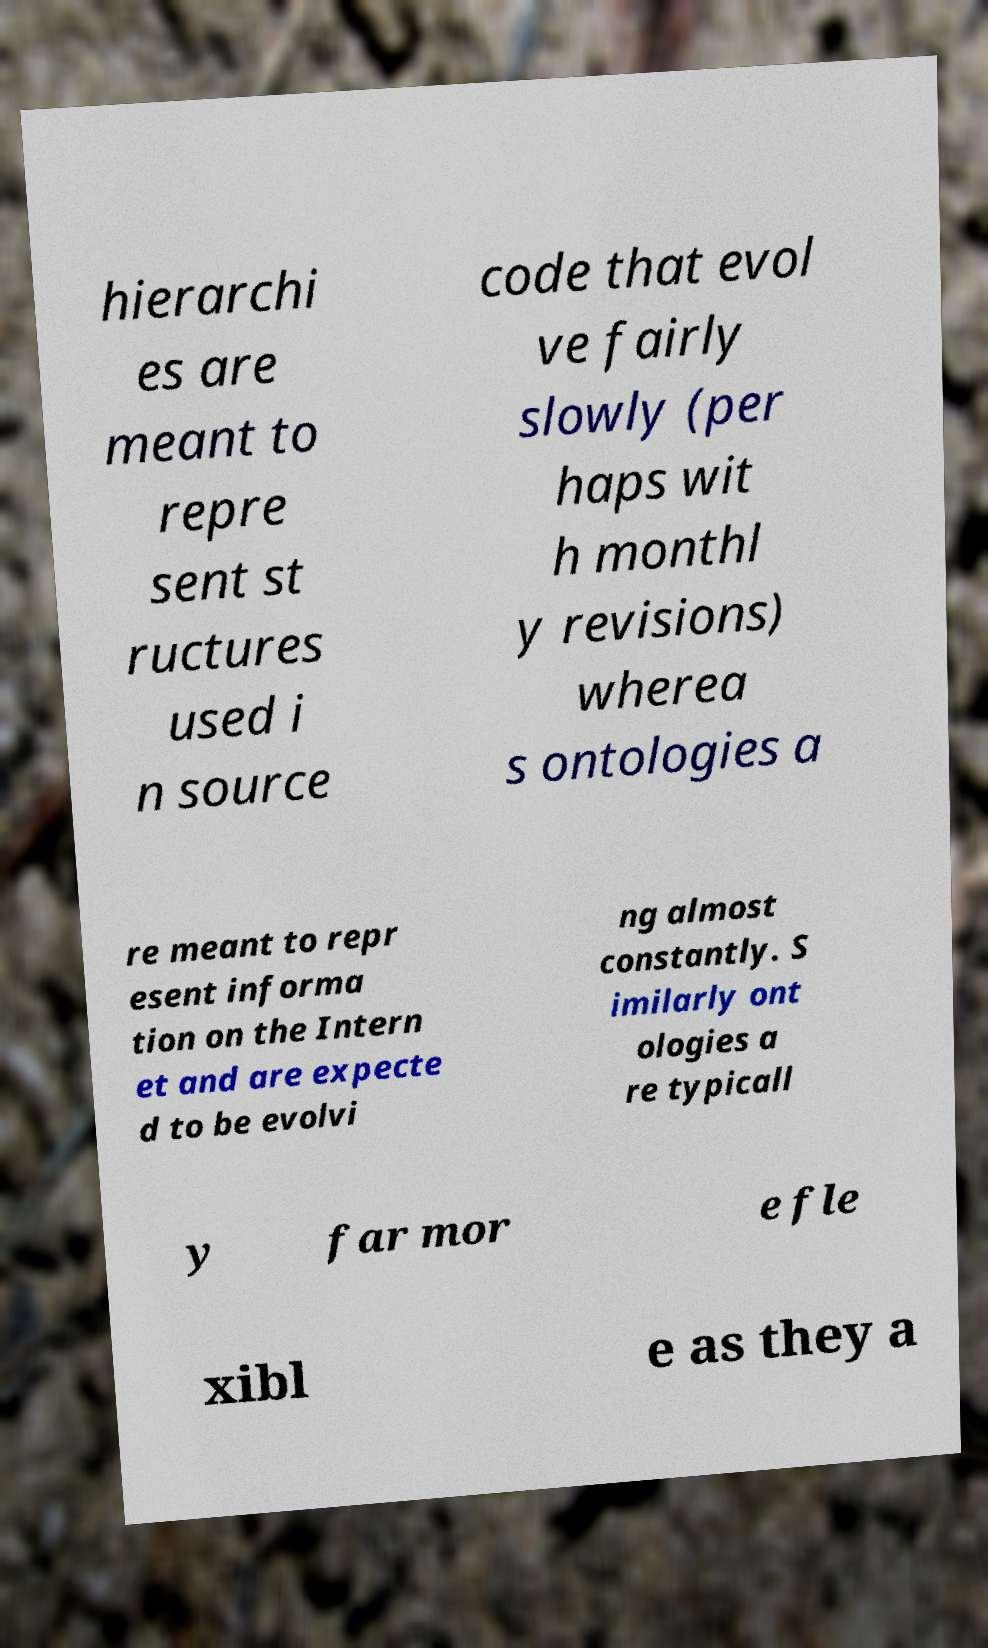Could you assist in decoding the text presented in this image and type it out clearly? hierarchi es are meant to repre sent st ructures used i n source code that evol ve fairly slowly (per haps wit h monthl y revisions) wherea s ontologies a re meant to repr esent informa tion on the Intern et and are expecte d to be evolvi ng almost constantly. S imilarly ont ologies a re typicall y far mor e fle xibl e as they a 